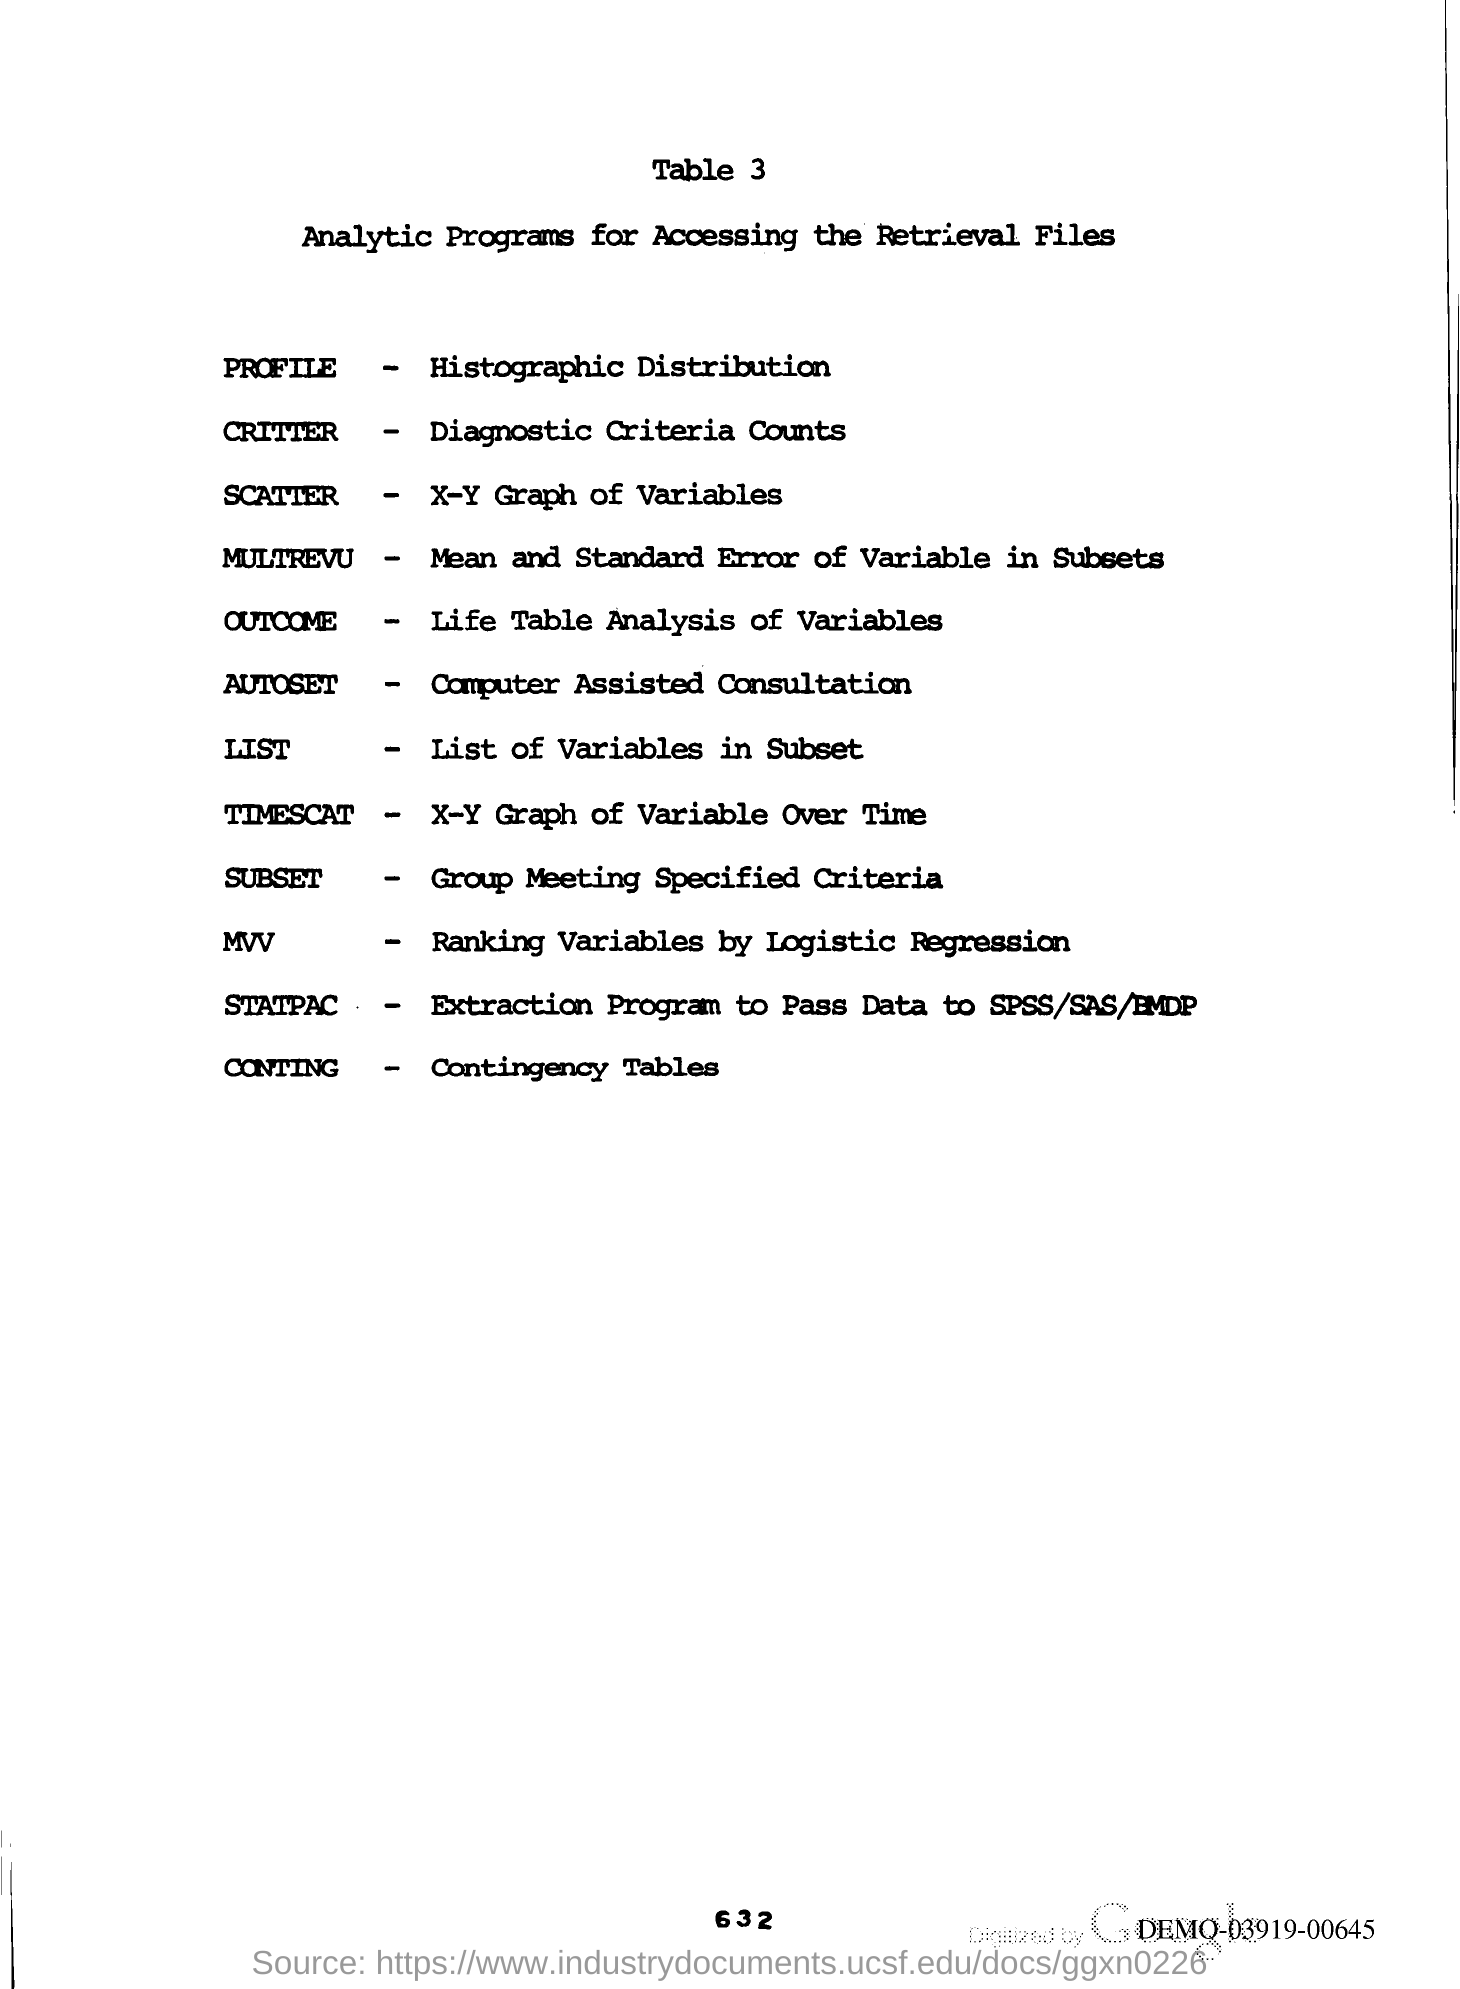What is the title of Table 3 given in the document?
Ensure brevity in your answer.  ANALYTIC PROGRAMS FOR ACCESSING THE RETRIEVAL FILES. What is the page no mentioned in this document?
Keep it short and to the point. 632. 